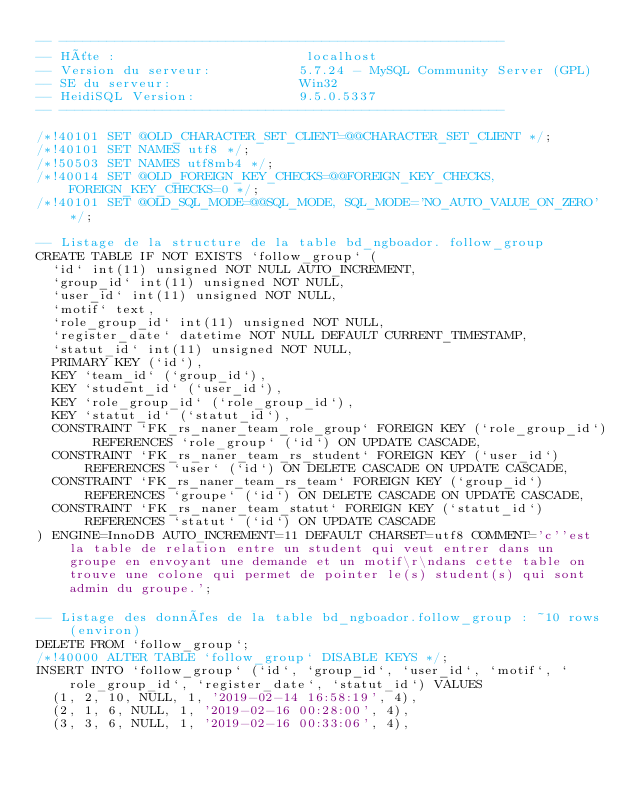<code> <loc_0><loc_0><loc_500><loc_500><_SQL_>-- --------------------------------------------------------
-- Hôte :                        localhost
-- Version du serveur:           5.7.24 - MySQL Community Server (GPL)
-- SE du serveur:                Win32
-- HeidiSQL Version:             9.5.0.5337
-- --------------------------------------------------------

/*!40101 SET @OLD_CHARACTER_SET_CLIENT=@@CHARACTER_SET_CLIENT */;
/*!40101 SET NAMES utf8 */;
/*!50503 SET NAMES utf8mb4 */;
/*!40014 SET @OLD_FOREIGN_KEY_CHECKS=@@FOREIGN_KEY_CHECKS, FOREIGN_KEY_CHECKS=0 */;
/*!40101 SET @OLD_SQL_MODE=@@SQL_MODE, SQL_MODE='NO_AUTO_VALUE_ON_ZERO' */;

-- Listage de la structure de la table bd_ngboador. follow_group
CREATE TABLE IF NOT EXISTS `follow_group` (
  `id` int(11) unsigned NOT NULL AUTO_INCREMENT,
  `group_id` int(11) unsigned NOT NULL,
  `user_id` int(11) unsigned NOT NULL,
  `motif` text,
  `role_group_id` int(11) unsigned NOT NULL,
  `register_date` datetime NOT NULL DEFAULT CURRENT_TIMESTAMP,
  `statut_id` int(11) unsigned NOT NULL,
  PRIMARY KEY (`id`),
  KEY `team_id` (`group_id`),
  KEY `student_id` (`user_id`),
  KEY `role_group_id` (`role_group_id`),
  KEY `statut_id` (`statut_id`),
  CONSTRAINT `FK_rs_naner_team_role_group` FOREIGN KEY (`role_group_id`) REFERENCES `role_group` (`id`) ON UPDATE CASCADE,
  CONSTRAINT `FK_rs_naner_team_rs_student` FOREIGN KEY (`user_id`) REFERENCES `user` (`id`) ON DELETE CASCADE ON UPDATE CASCADE,
  CONSTRAINT `FK_rs_naner_team_rs_team` FOREIGN KEY (`group_id`) REFERENCES `groupe` (`id`) ON DELETE CASCADE ON UPDATE CASCADE,
  CONSTRAINT `FK_rs_naner_team_statut` FOREIGN KEY (`statut_id`) REFERENCES `statut` (`id`) ON UPDATE CASCADE
) ENGINE=InnoDB AUTO_INCREMENT=11 DEFAULT CHARSET=utf8 COMMENT='c''est la table de relation entre un student qui veut entrer dans un groupe en envoyant une demande et un motif\r\ndans cette table on trouve une colone qui permet de pointer le(s) student(s) qui sont admin du groupe.';

-- Listage des données de la table bd_ngboador.follow_group : ~10 rows (environ)
DELETE FROM `follow_group`;
/*!40000 ALTER TABLE `follow_group` DISABLE KEYS */;
INSERT INTO `follow_group` (`id`, `group_id`, `user_id`, `motif`, `role_group_id`, `register_date`, `statut_id`) VALUES
	(1, 2, 10, NULL, 1, '2019-02-14 16:58:19', 4),
	(2, 1, 6, NULL, 1, '2019-02-16 00:28:00', 4),
	(3, 3, 6, NULL, 1, '2019-02-16 00:33:06', 4),</code> 